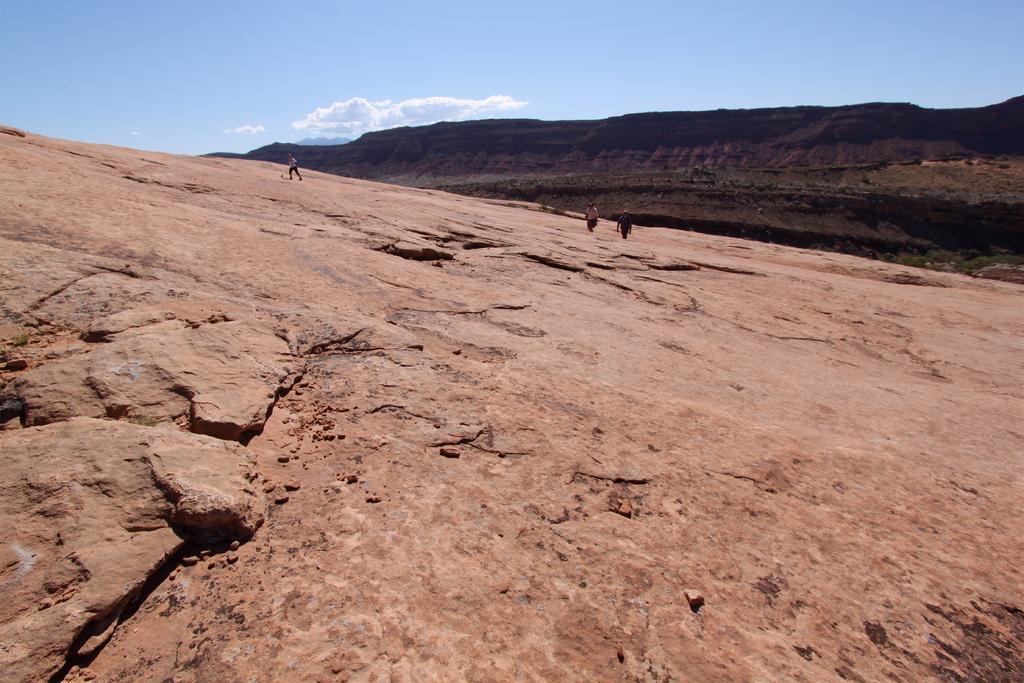In one or two sentences, can you explain what this image depicts? In this image we can see three persons, rock, and mountain. In the background there is sky with clouds. 